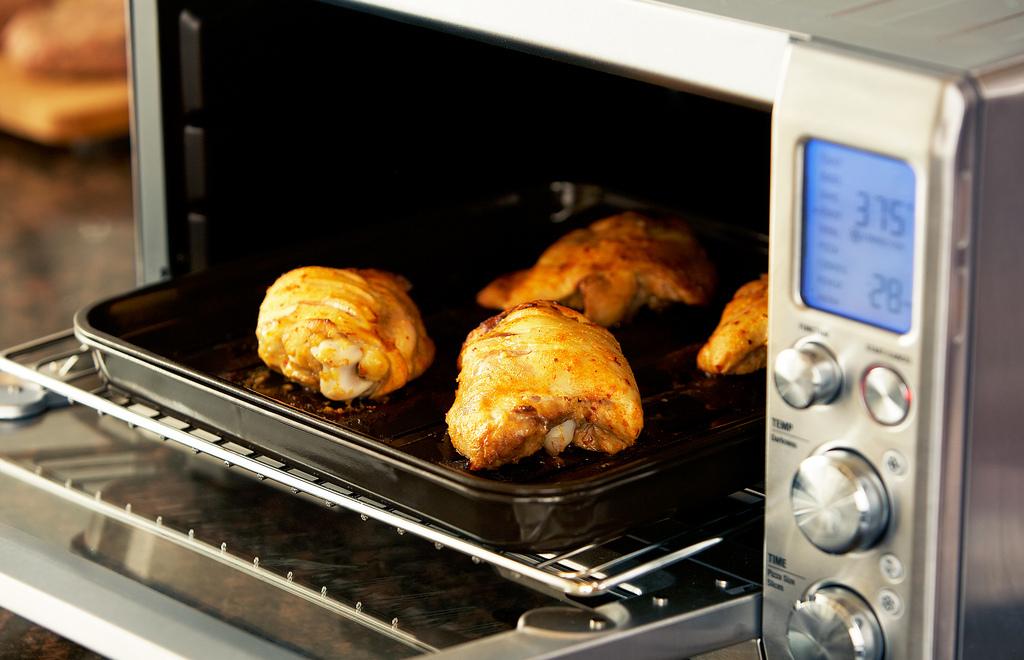How many minutes to cook?
Make the answer very short. 28. What temperature is it set to?
Offer a terse response. 375. 